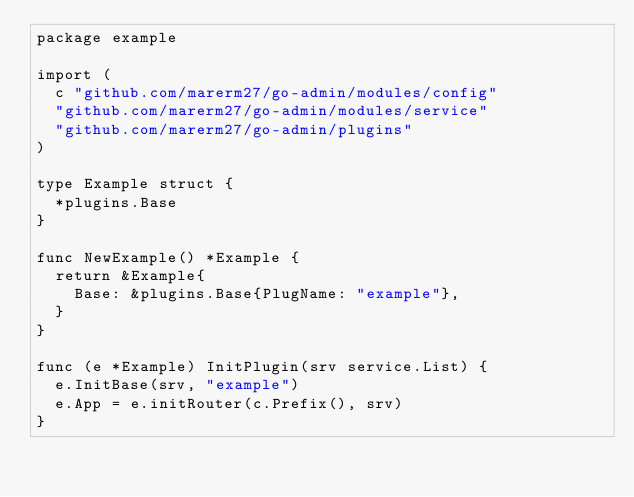Convert code to text. <code><loc_0><loc_0><loc_500><loc_500><_Go_>package example

import (
	c "github.com/marerm27/go-admin/modules/config"
	"github.com/marerm27/go-admin/modules/service"
	"github.com/marerm27/go-admin/plugins"
)

type Example struct {
	*plugins.Base
}

func NewExample() *Example {
	return &Example{
		Base: &plugins.Base{PlugName: "example"},
	}
}

func (e *Example) InitPlugin(srv service.List) {
	e.InitBase(srv, "example")
	e.App = e.initRouter(c.Prefix(), srv)
}
</code> 